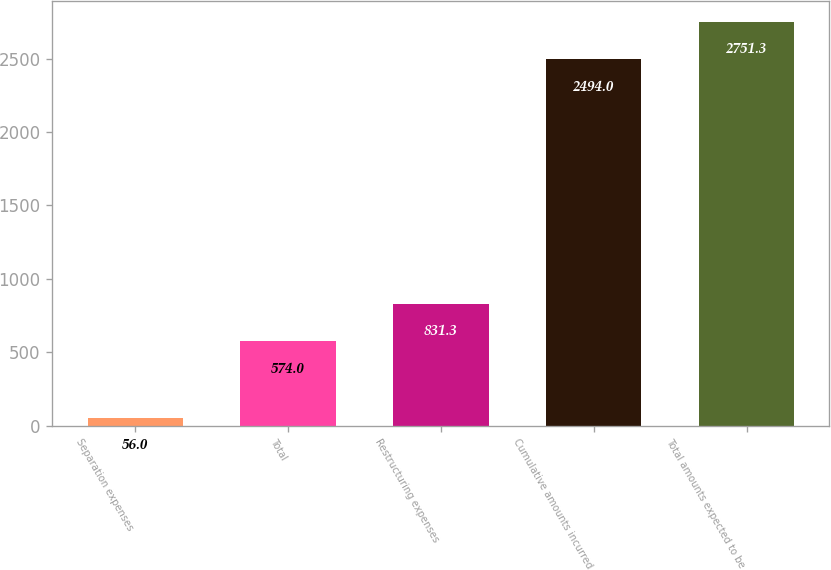Convert chart to OTSL. <chart><loc_0><loc_0><loc_500><loc_500><bar_chart><fcel>Separation expenses<fcel>Total<fcel>Restructuring expenses<fcel>Cumulative amounts incurred<fcel>Total amounts expected to be<nl><fcel>56<fcel>574<fcel>831.3<fcel>2494<fcel>2751.3<nl></chart> 